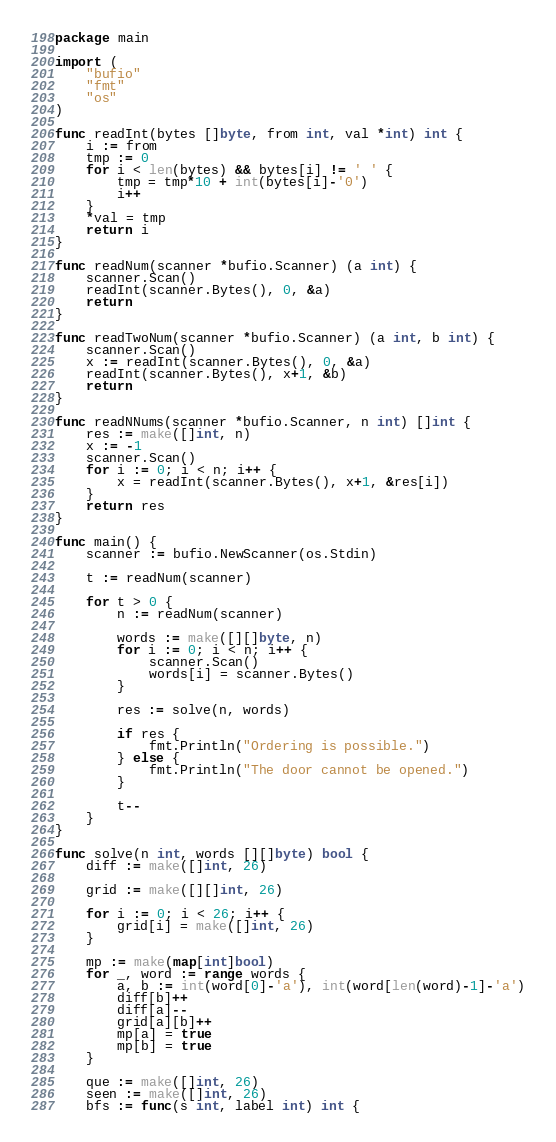<code> <loc_0><loc_0><loc_500><loc_500><_Go_>package main

import (
	"bufio"
	"fmt"
	"os"
)

func readInt(bytes []byte, from int, val *int) int {
	i := from
	tmp := 0
	for i < len(bytes) && bytes[i] != ' ' {
		tmp = tmp*10 + int(bytes[i]-'0')
		i++
	}
	*val = tmp
	return i
}

func readNum(scanner *bufio.Scanner) (a int) {
	scanner.Scan()
	readInt(scanner.Bytes(), 0, &a)
	return
}

func readTwoNum(scanner *bufio.Scanner) (a int, b int) {
	scanner.Scan()
	x := readInt(scanner.Bytes(), 0, &a)
	readInt(scanner.Bytes(), x+1, &b)
	return
}

func readNNums(scanner *bufio.Scanner, n int) []int {
	res := make([]int, n)
	x := -1
	scanner.Scan()
	for i := 0; i < n; i++ {
		x = readInt(scanner.Bytes(), x+1, &res[i])
	}
	return res
}

func main() {
	scanner := bufio.NewScanner(os.Stdin)

	t := readNum(scanner)

	for t > 0 {
		n := readNum(scanner)

		words := make([][]byte, n)
		for i := 0; i < n; i++ {
			scanner.Scan()
			words[i] = scanner.Bytes()
		}

		res := solve(n, words)

		if res {
			fmt.Println("Ordering is possible.")
		} else {
			fmt.Println("The door cannot be opened.")
		}

		t--
	}
}

func solve(n int, words [][]byte) bool {
	diff := make([]int, 26)

	grid := make([][]int, 26)

	for i := 0; i < 26; i++ {
		grid[i] = make([]int, 26)
	}

	mp := make(map[int]bool)
	for _, word := range words {
		a, b := int(word[0]-'a'), int(word[len(word)-1]-'a')
		diff[b]++
		diff[a]--
		grid[a][b]++
		mp[a] = true
		mp[b] = true
	}

	que := make([]int, 26)
	seen := make([]int, 26)
	bfs := func(s int, label int) int {</code> 